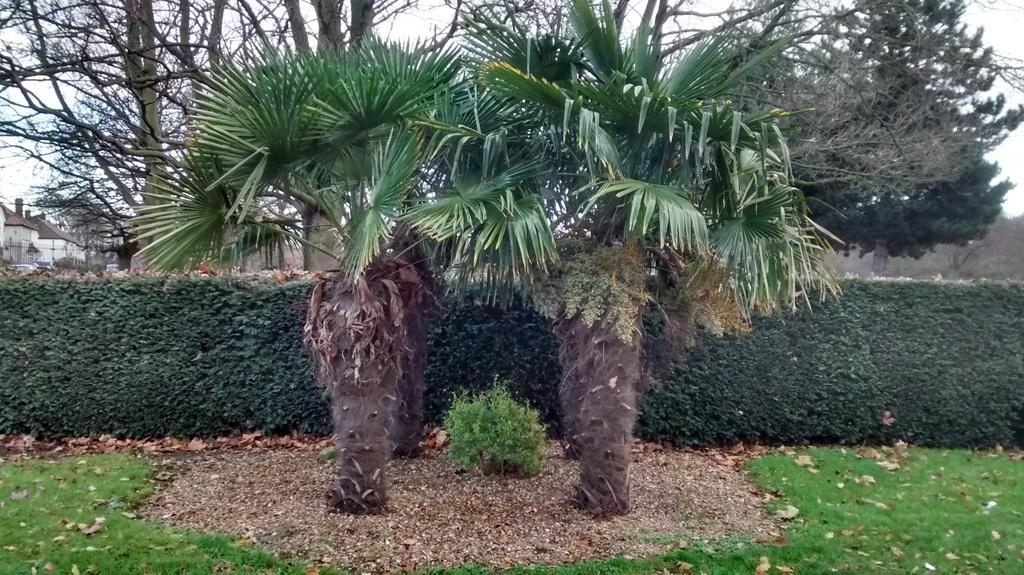What is located in the center of the image? There are plants in the center of the image. What type of vegetation is present at the bottom of the image? There is grass on the surface at the bottom of the image. What can be seen in the background of the image? There are buildings, trees, and the sky visible in the background of the image. How many fingers can be seen in the image? There are no fingers visible in the image. Are there any geese present in the image? There are no geese present in the image. 